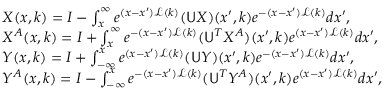<formula> <loc_0><loc_0><loc_500><loc_500>\begin{array} { r l } & { X ( x , k ) = I - \int _ { x } ^ { \infty } e ^ { ( x - x ^ { \prime } ) \mathcal { L } ( k ) } ( U X ) ( x ^ { \prime } , k ) e ^ { - ( x - x ^ { \prime } ) \mathcal { L } ( k ) } d x ^ { \prime } , } \\ & { X ^ { A } ( x , k ) = I + \int _ { x } ^ { \infty } e ^ { - ( x - x ^ { \prime } ) \mathcal { L } ( k ) } ( U ^ { T } X ^ { A } ) ( x ^ { \prime } , k ) e ^ { ( x - x ^ { \prime } ) \mathcal { L } ( k ) } d x ^ { \prime } , } \\ & { Y ( x , k ) = I + \int _ { - \infty } ^ { x } e ^ { ( x - x ^ { \prime } ) \mathcal { L } ( k ) } ( U Y ) ( x ^ { \prime } , k ) e ^ { - ( x - x ^ { \prime } ) \mathcal { L } ( k ) } d x ^ { \prime } , } \\ & { Y ^ { A } ( x , k ) = I - \int _ { - \infty } ^ { x } e ^ { - ( x - x ^ { \prime } ) \mathcal { L } ( k ) } ( U ^ { T } Y ^ { A } ) ( x ^ { \prime } , k ) e ^ { ( x - x ^ { \prime } ) \mathcal { L } ( k ) } d x ^ { \prime } , } \end{array}</formula> 